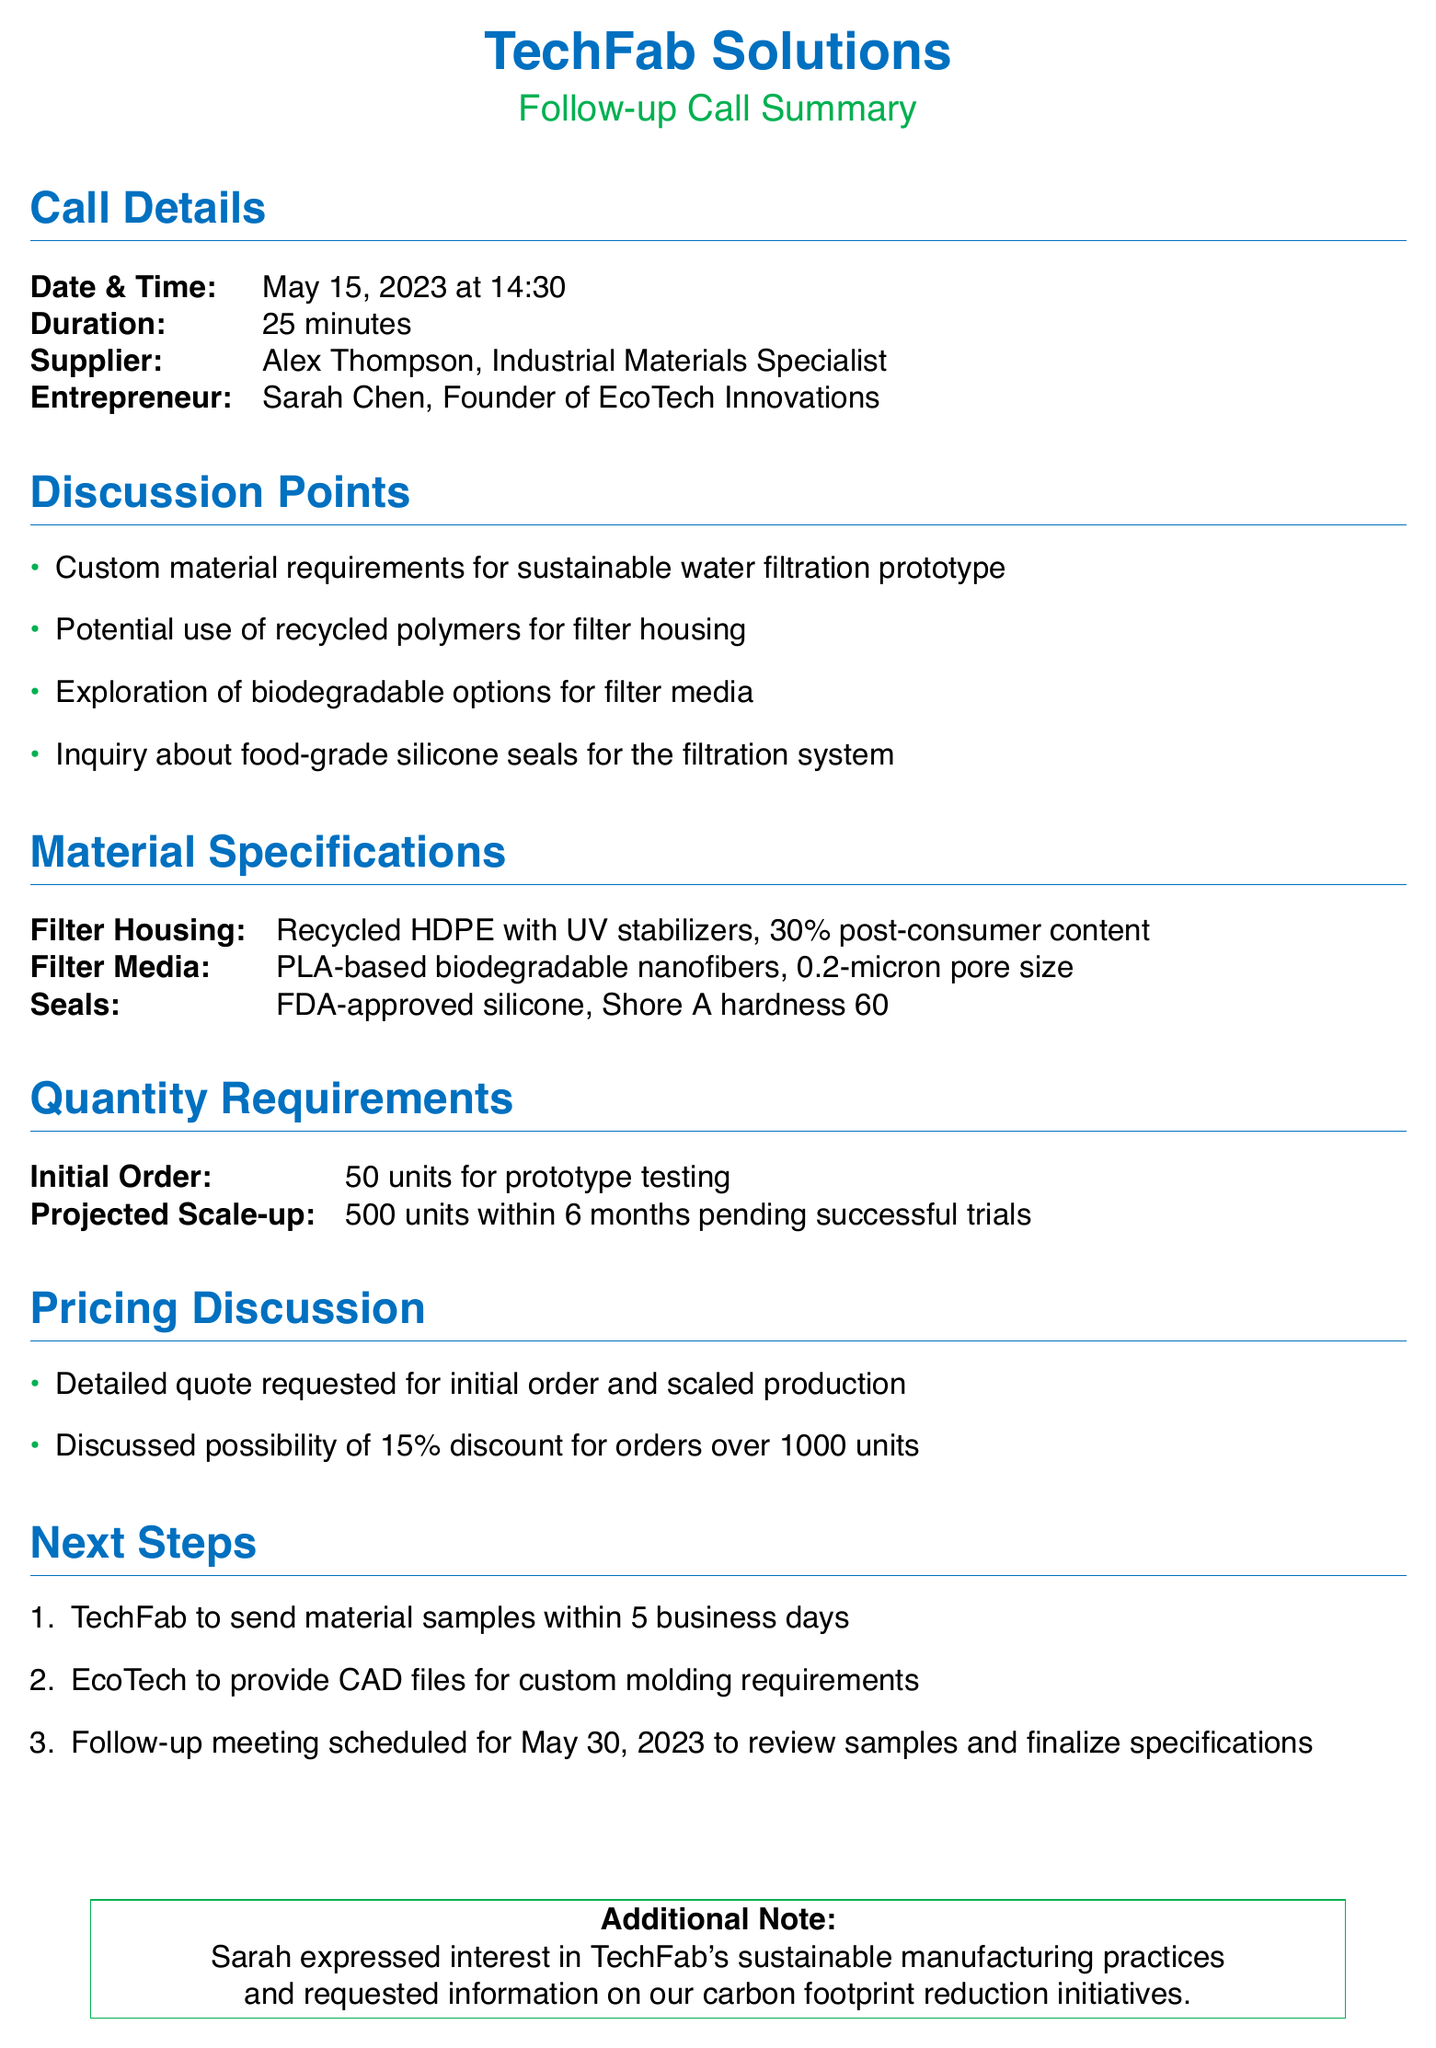What is the date of the follow-up call? The date of the follow-up call is explicitly mentioned in the call details section.
Answer: May 15, 2023 Who is the entrepreneur discussed in the call? The entrepreneur's name is listed under the call details section.
Answer: Sarah Chen What is the initial order quantity for the prototype? The quantity requirements specify the initial order quantity for the prototype testing.
Answer: 50 units What material is specified for the filter housing? The material specifications section lists the material designated for the filter housing.
Answer: Recycled HDPE with UV stabilizers What discount was discussed for large orders? The pricing discussion mentions a potential discount for orders over a certain quantity.
Answer: 15% How many units are projected for scale-up in six months? The quantity requirements section states the projected scale-up number.
Answer: 500 units What specific quality was requested for the seals? The material specifications table details the quality of the seals needed.
Answer: FDA-approved silicone When is the next follow-up meeting scheduled? The next steps section includes the date for the upcoming meeting.
Answer: May 30, 2023 What additional information did Sarah request? The additional note at the bottom of the document mentions what Sarah expressed interest in.
Answer: Information on carbon footprint reduction initiatives 